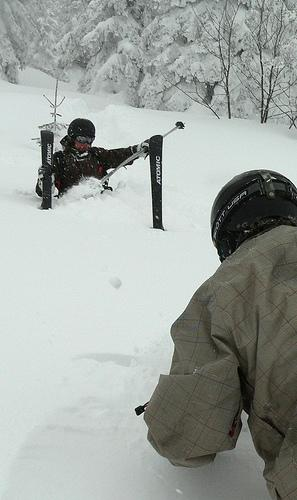How many person can be seen?

Choices:
A) three
B) two
C) four
D) one two 